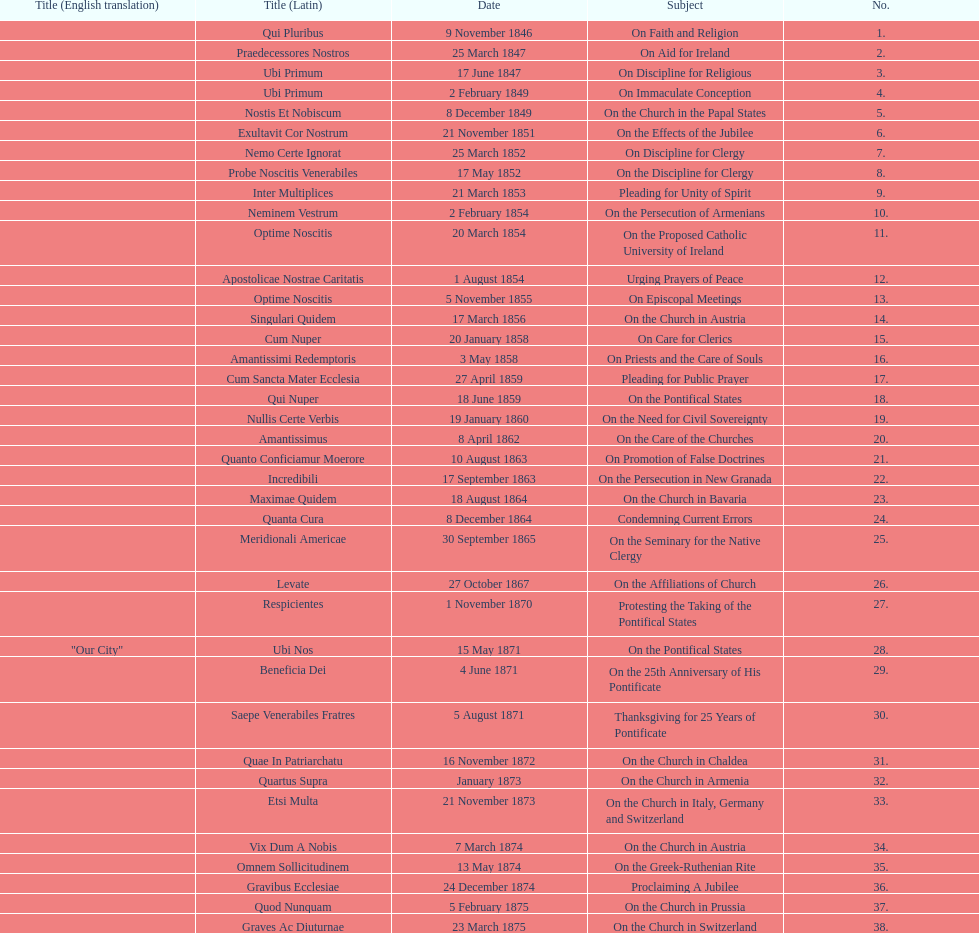Latin title of the encyclical before the encyclical with the subject "on the church in bavaria" Incredibili. 